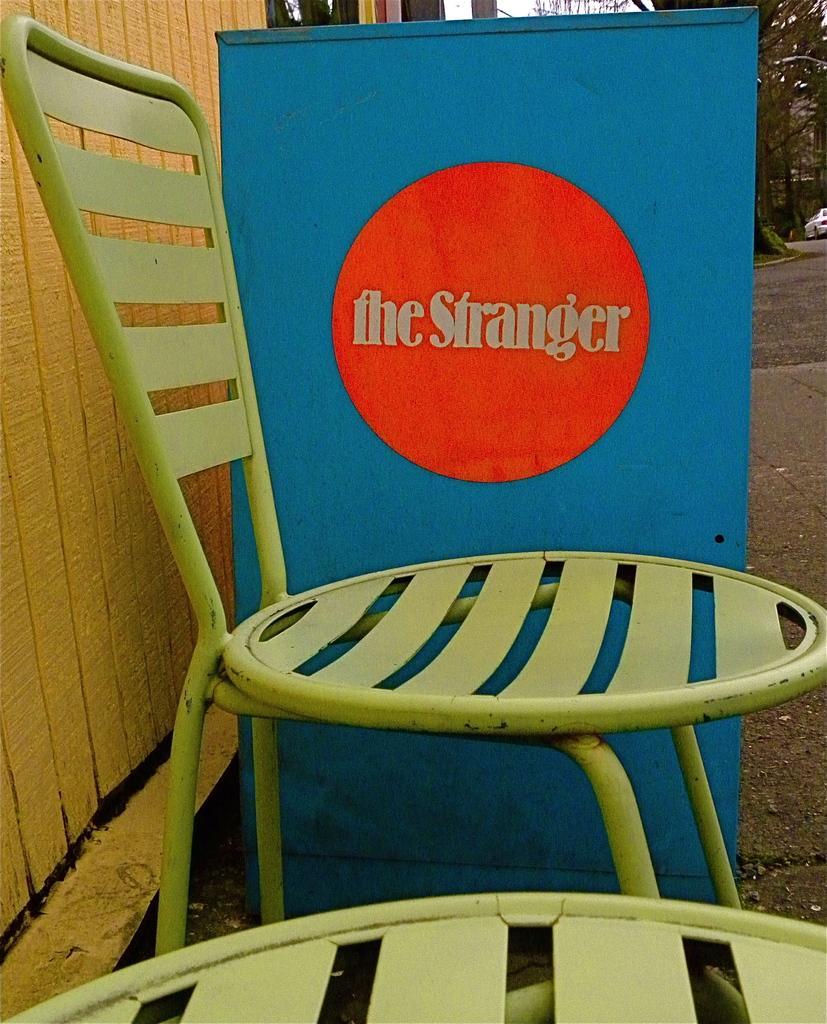In one or two sentences, can you explain what this image depicts? In this image we can see the chairs, some text written on the board, beside we can see wooden object, in the background we can see the trees, vehicle, road. 